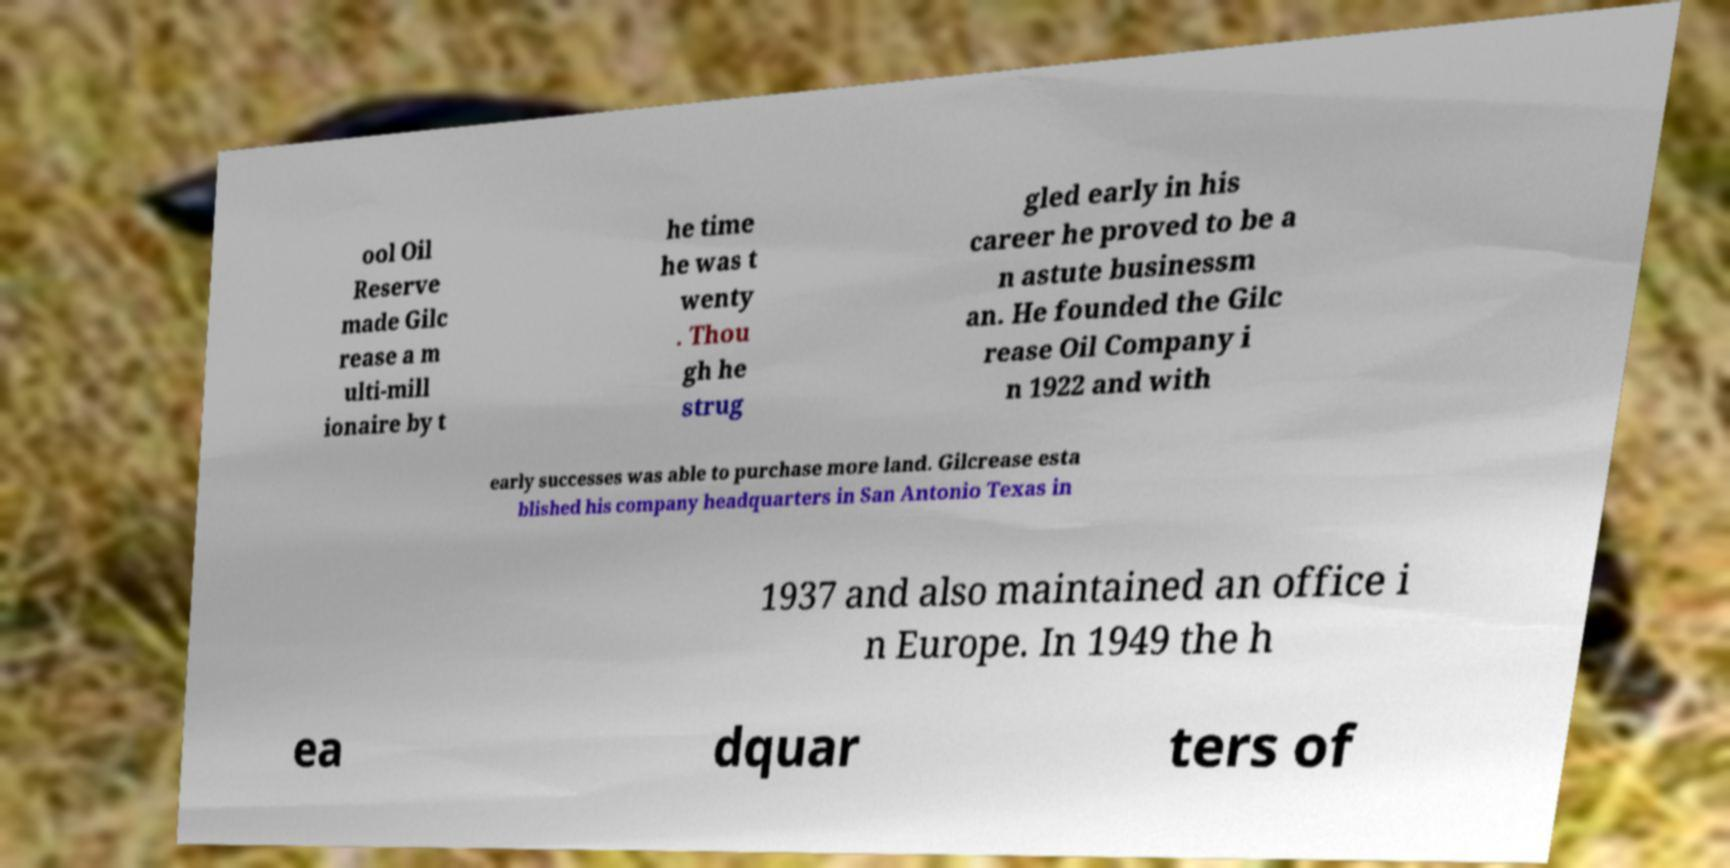Can you accurately transcribe the text from the provided image for me? ool Oil Reserve made Gilc rease a m ulti-mill ionaire by t he time he was t wenty . Thou gh he strug gled early in his career he proved to be a n astute businessm an. He founded the Gilc rease Oil Company i n 1922 and with early successes was able to purchase more land. Gilcrease esta blished his company headquarters in San Antonio Texas in 1937 and also maintained an office i n Europe. In 1949 the h ea dquar ters of 